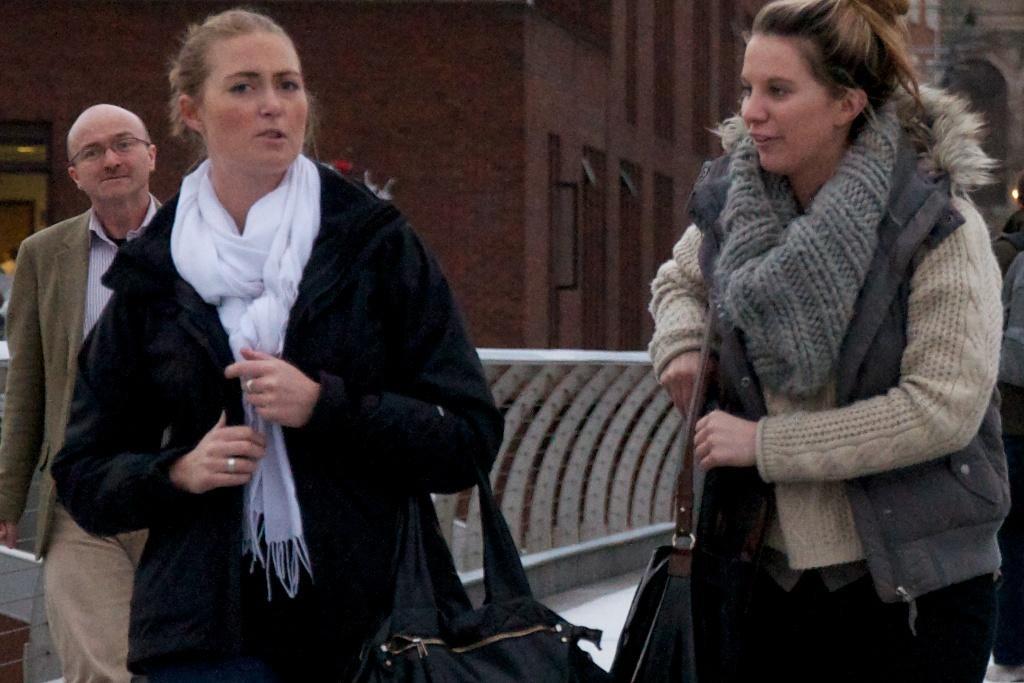Please provide a concise description of this image. In this image I can see three persons on the road. In the background I can see a fence, buildings, door and windows. This image is taken may be on the road. 